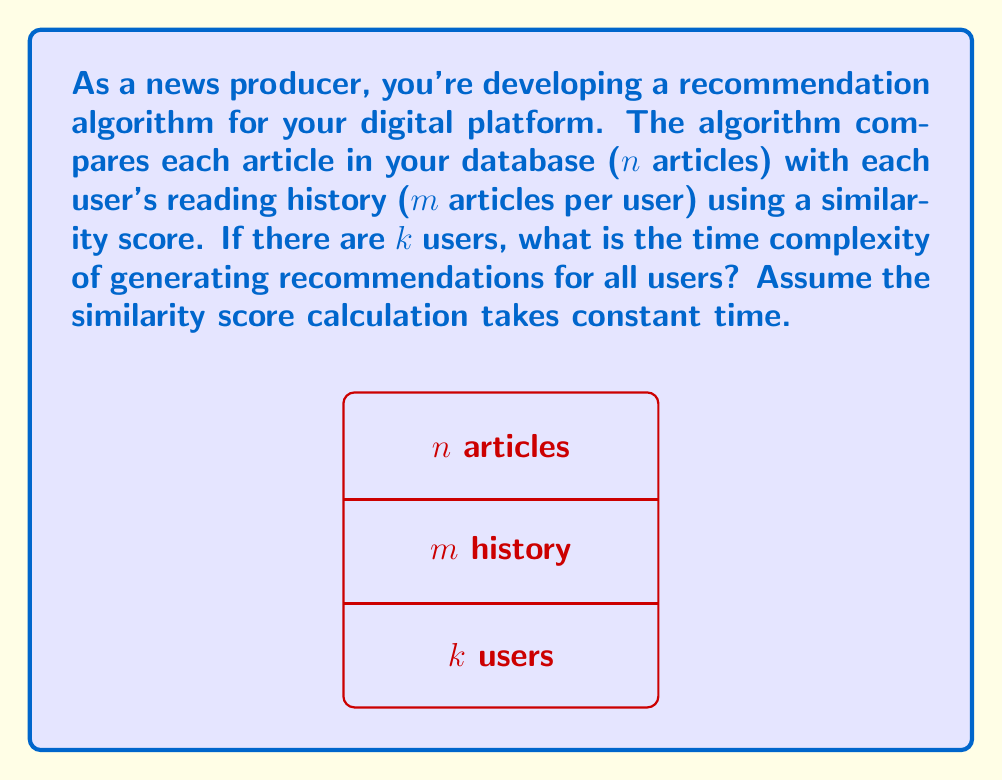What is the answer to this math problem? Let's break this down step-by-step:

1) For each user, we need to compare their reading history with every article in the database.

2) For a single user:
   - We have m articles in their history
   - We compare each of these m articles with n articles in the database
   - This results in m * n comparisons for one user

3) We repeat this process for all k users

4) Therefore, the total number of comparisons is:
   $$ k * (m * n) = kmn $$

5) Since the similarity score calculation takes constant time, let's call this time c.

6) The total time for all comparisons is then:
   $$ c * kmn $$

7) In Big O notation, we drop constant factors, so the time complexity becomes:
   $$ O(kmn) $$

This represents a cubic time complexity, which can become quite significant for large values of k, m, and n.
Answer: $O(kmn)$ 